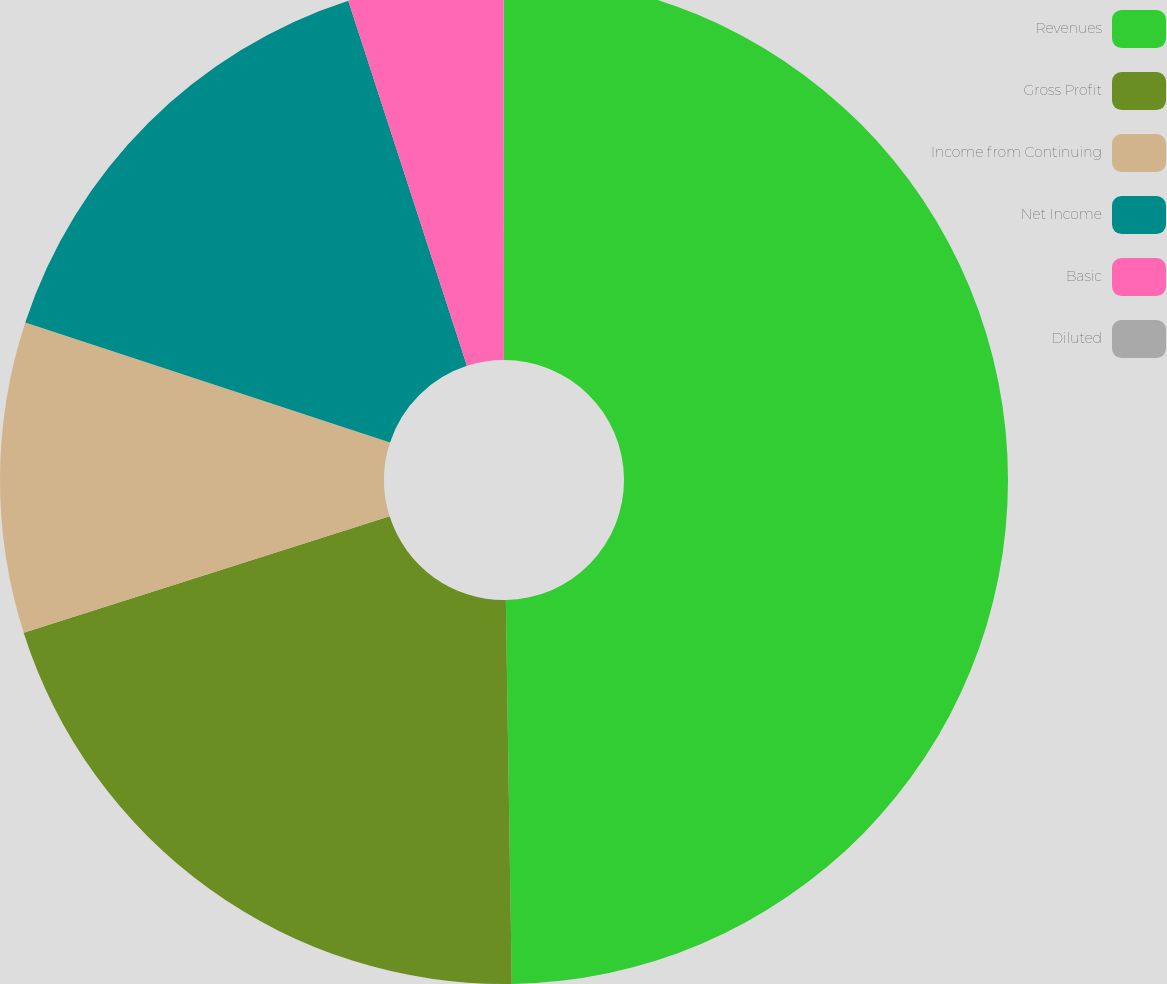Convert chart to OTSL. <chart><loc_0><loc_0><loc_500><loc_500><pie_chart><fcel>Revenues<fcel>Gross Profit<fcel>Income from Continuing<fcel>Net Income<fcel>Basic<fcel>Diluted<nl><fcel>49.76%<fcel>20.35%<fcel>9.96%<fcel>14.94%<fcel>4.99%<fcel>0.01%<nl></chart> 